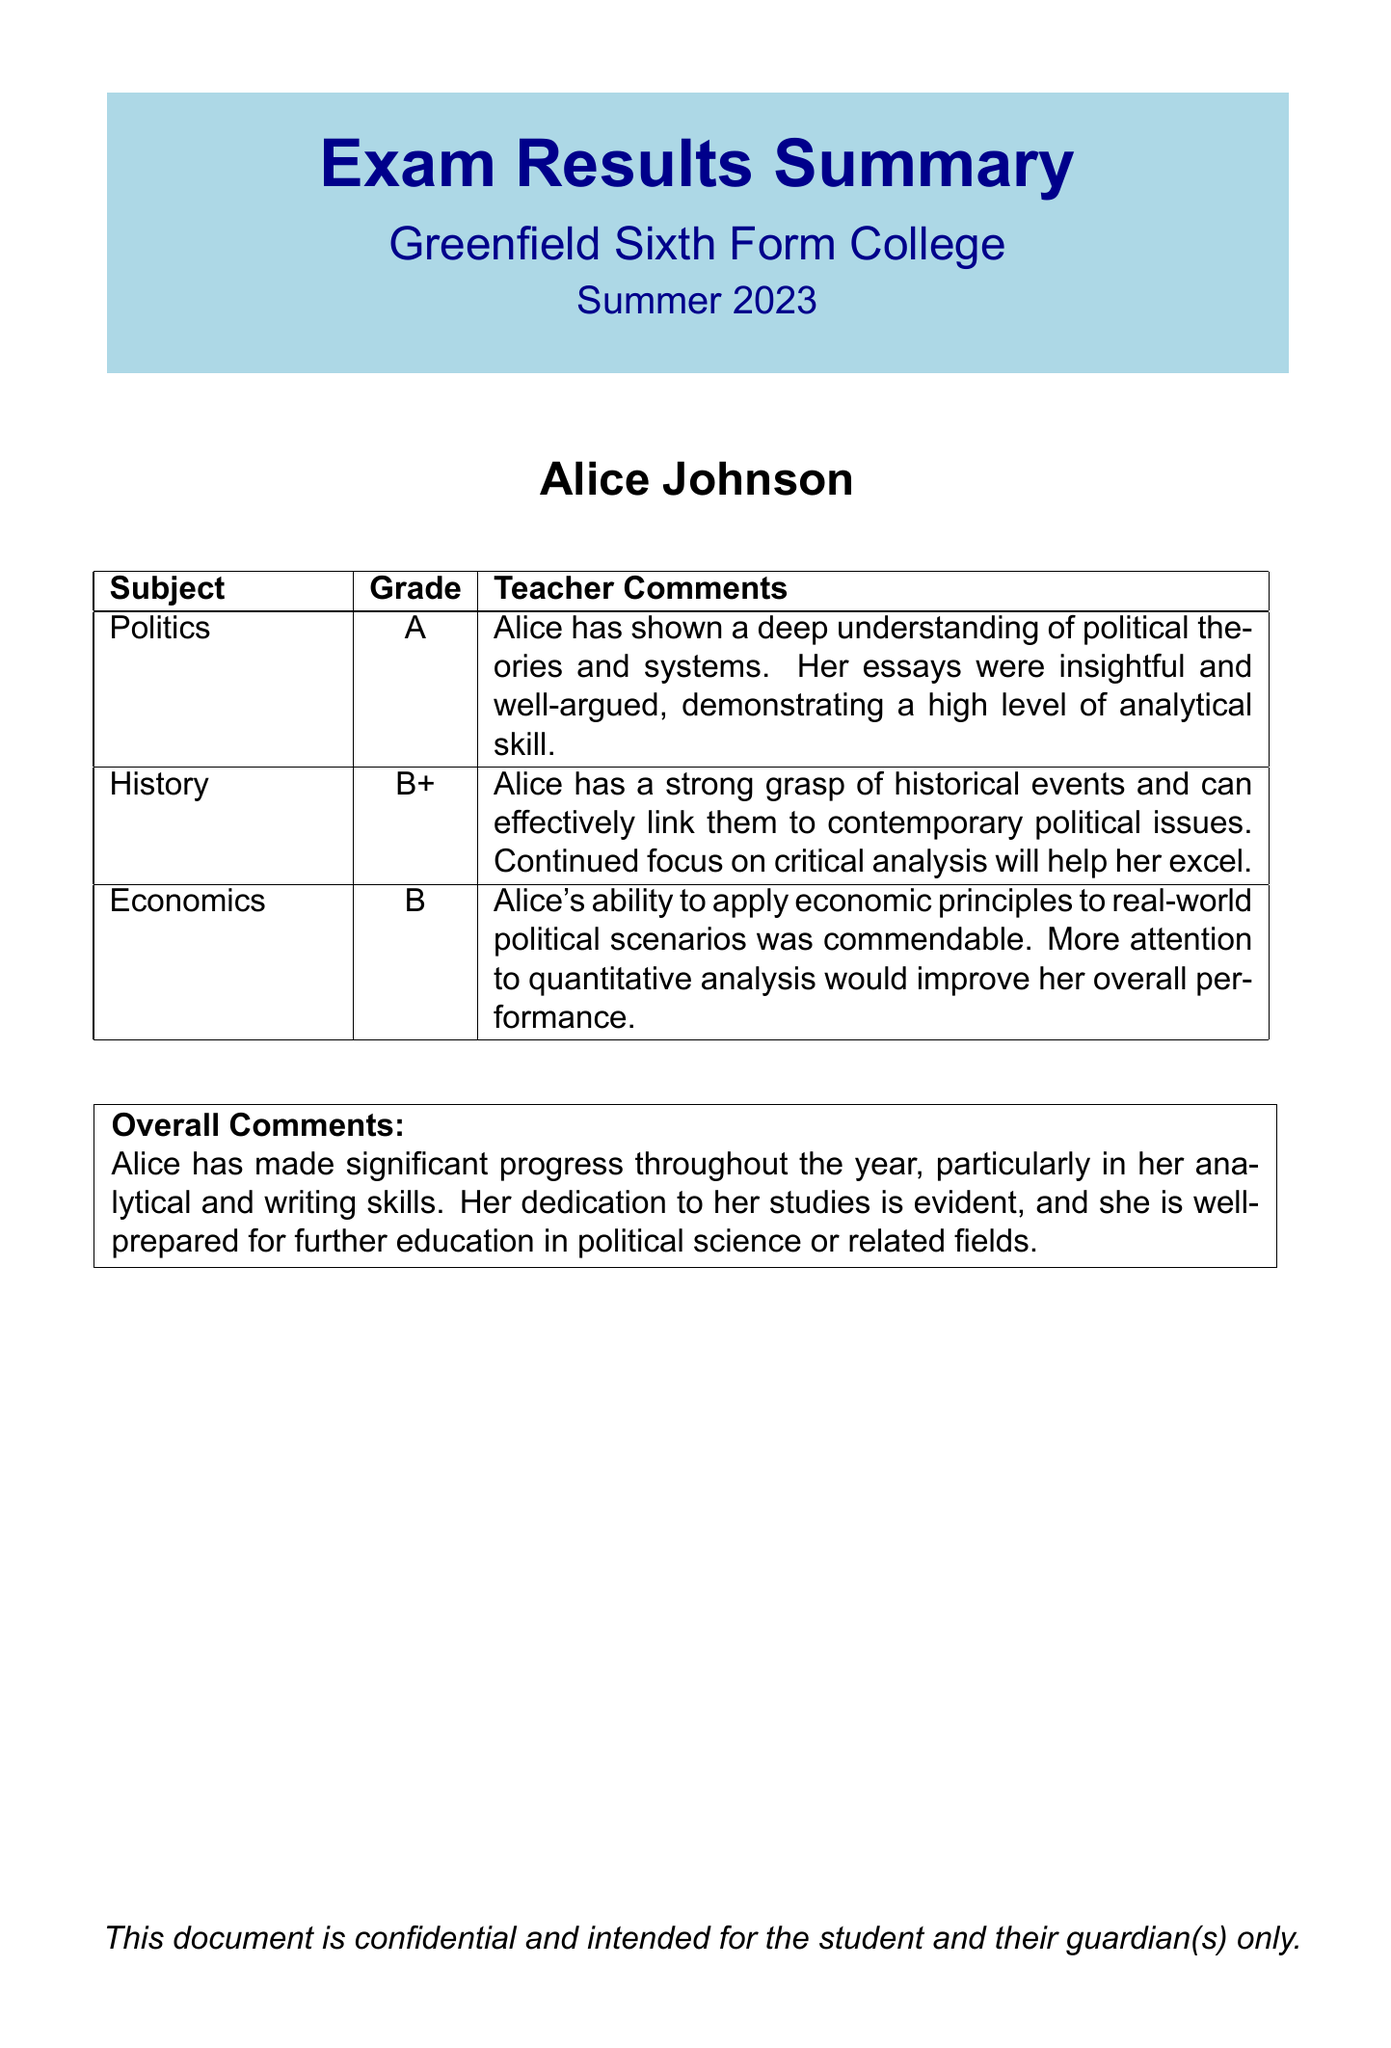What is the name of the student? The student's name is mentioned at the center of the document.
Answer: Alice Johnson What grade did Alice receive in Politics? Politically, the document specifies Alice's grade in the corresponding section for that subject.
Answer: A What comments did the teacher provide for History? The comments in the document following the grade provide insights on Alice’s performance in History.
Answer: Alice has a strong grasp of historical events and can effectively link them to contemporary political issues. Continued focus on critical analysis will help her excel What is the overall assessment of Alice's progress? The overall comments section summarizes the teacher’s view in a specific format about Alice's progress throughout the year.
Answer: Significant progress What is Alice's grade in Economics? The document specifically lists the grade for Economics, which is in the corresponding subject section.
Answer: B What is the subject in which Alice received the highest grade? The grades listed for each subject help identify which one has the highest score.
Answer: Politics How many subjects are listed in the results summary? The document outlines a specific number of subjects with corresponding grades and comments which can be counted.
Answer: 3 What is the purpose of this document? The document has a stated intent which can be inferred from the opening summary, particularly for the student and their guardian.
Answer: Exam Results Summary In which term did Alice receive these results? The document indicates when the results were obtained in the title section.
Answer: Summer 2023 